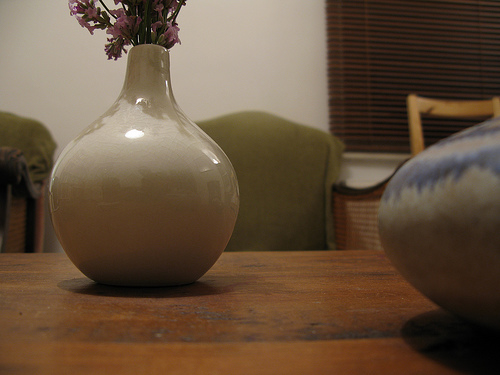<image>
Is there a vase in front of the chair? Yes. The vase is positioned in front of the chair, appearing closer to the camera viewpoint. 